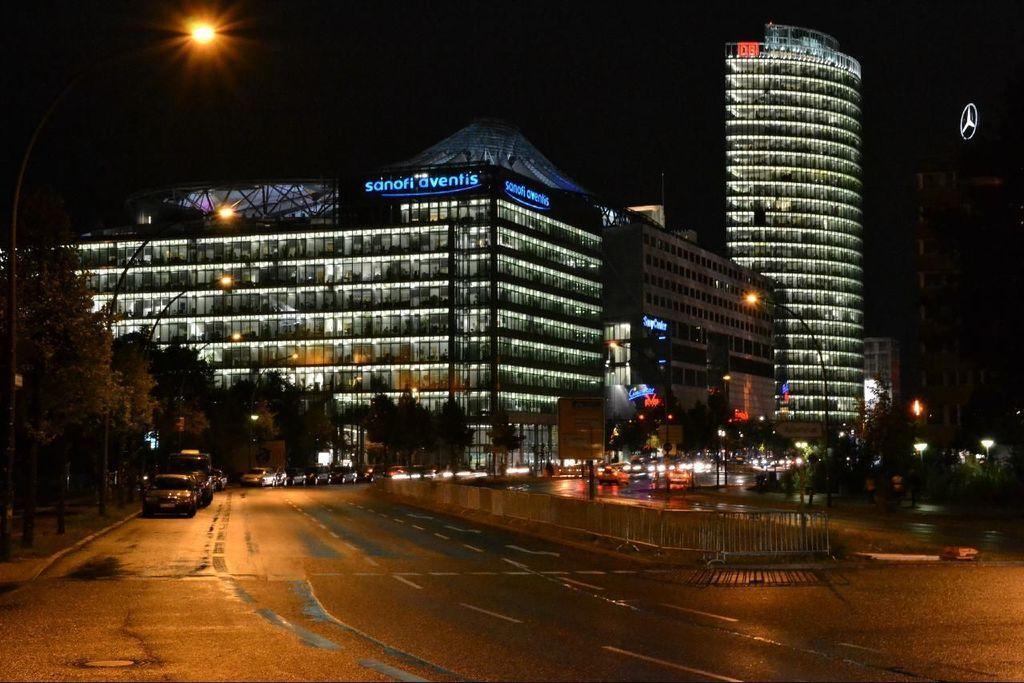Describe this image in one or two sentences. In this picture I can see vehicles on the road, there are poles, lights, there are barricades, there are buildings, there are trees, and there is dark background. 